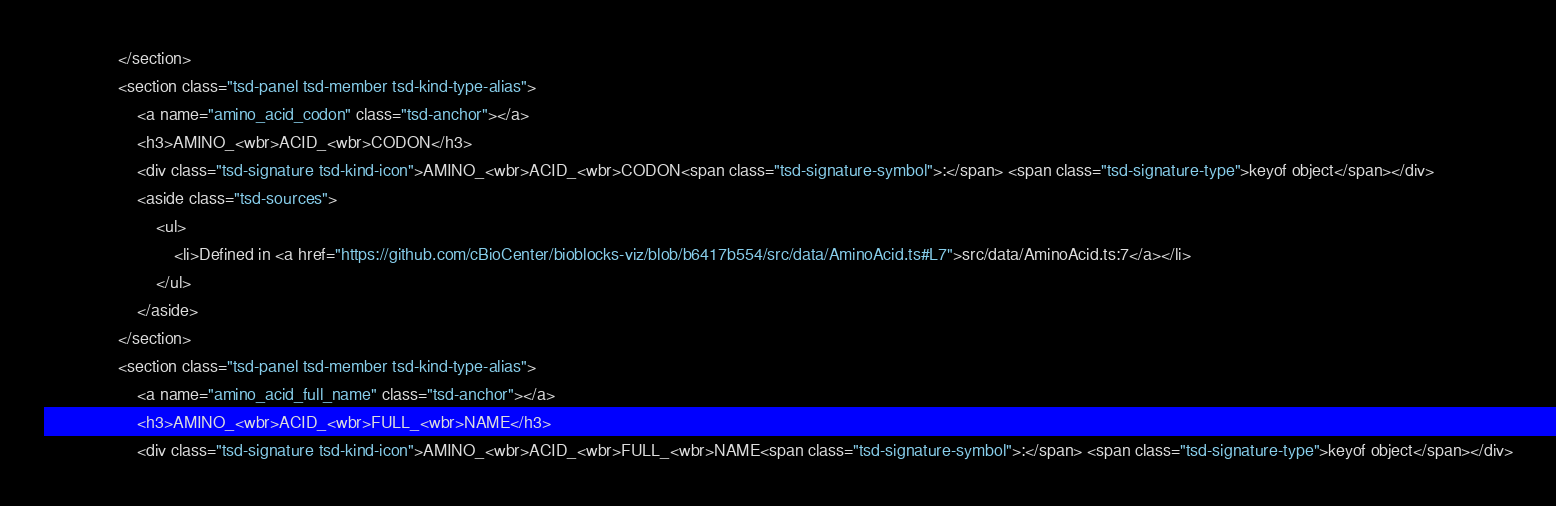Convert code to text. <code><loc_0><loc_0><loc_500><loc_500><_HTML_>				</section>
				<section class="tsd-panel tsd-member tsd-kind-type-alias">
					<a name="amino_acid_codon" class="tsd-anchor"></a>
					<h3>AMINO_<wbr>ACID_<wbr>CODON</h3>
					<div class="tsd-signature tsd-kind-icon">AMINO_<wbr>ACID_<wbr>CODON<span class="tsd-signature-symbol">:</span> <span class="tsd-signature-type">keyof object</span></div>
					<aside class="tsd-sources">
						<ul>
							<li>Defined in <a href="https://github.com/cBioCenter/bioblocks-viz/blob/b6417b554/src/data/AminoAcid.ts#L7">src/data/AminoAcid.ts:7</a></li>
						</ul>
					</aside>
				</section>
				<section class="tsd-panel tsd-member tsd-kind-type-alias">
					<a name="amino_acid_full_name" class="tsd-anchor"></a>
					<h3>AMINO_<wbr>ACID_<wbr>FULL_<wbr>NAME</h3>
					<div class="tsd-signature tsd-kind-icon">AMINO_<wbr>ACID_<wbr>FULL_<wbr>NAME<span class="tsd-signature-symbol">:</span> <span class="tsd-signature-type">keyof object</span></div></code> 